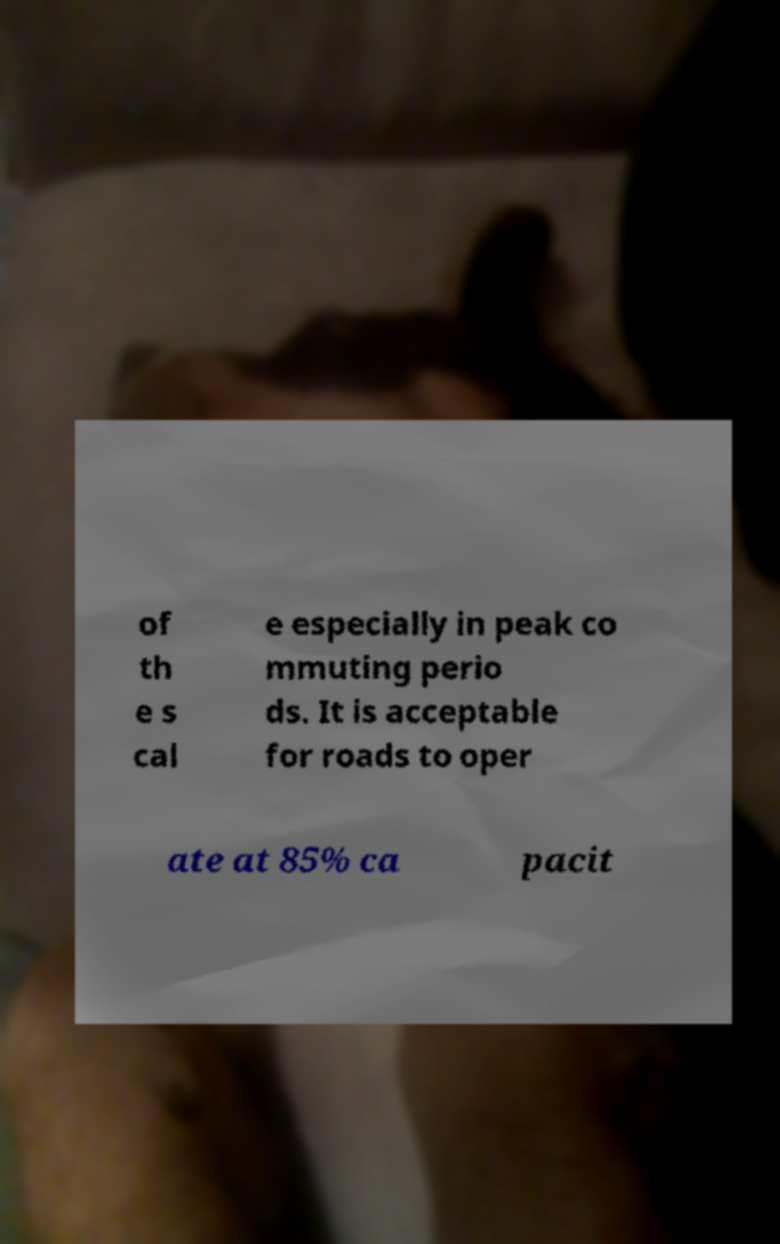Please identify and transcribe the text found in this image. of th e s cal e especially in peak co mmuting perio ds. It is acceptable for roads to oper ate at 85% ca pacit 